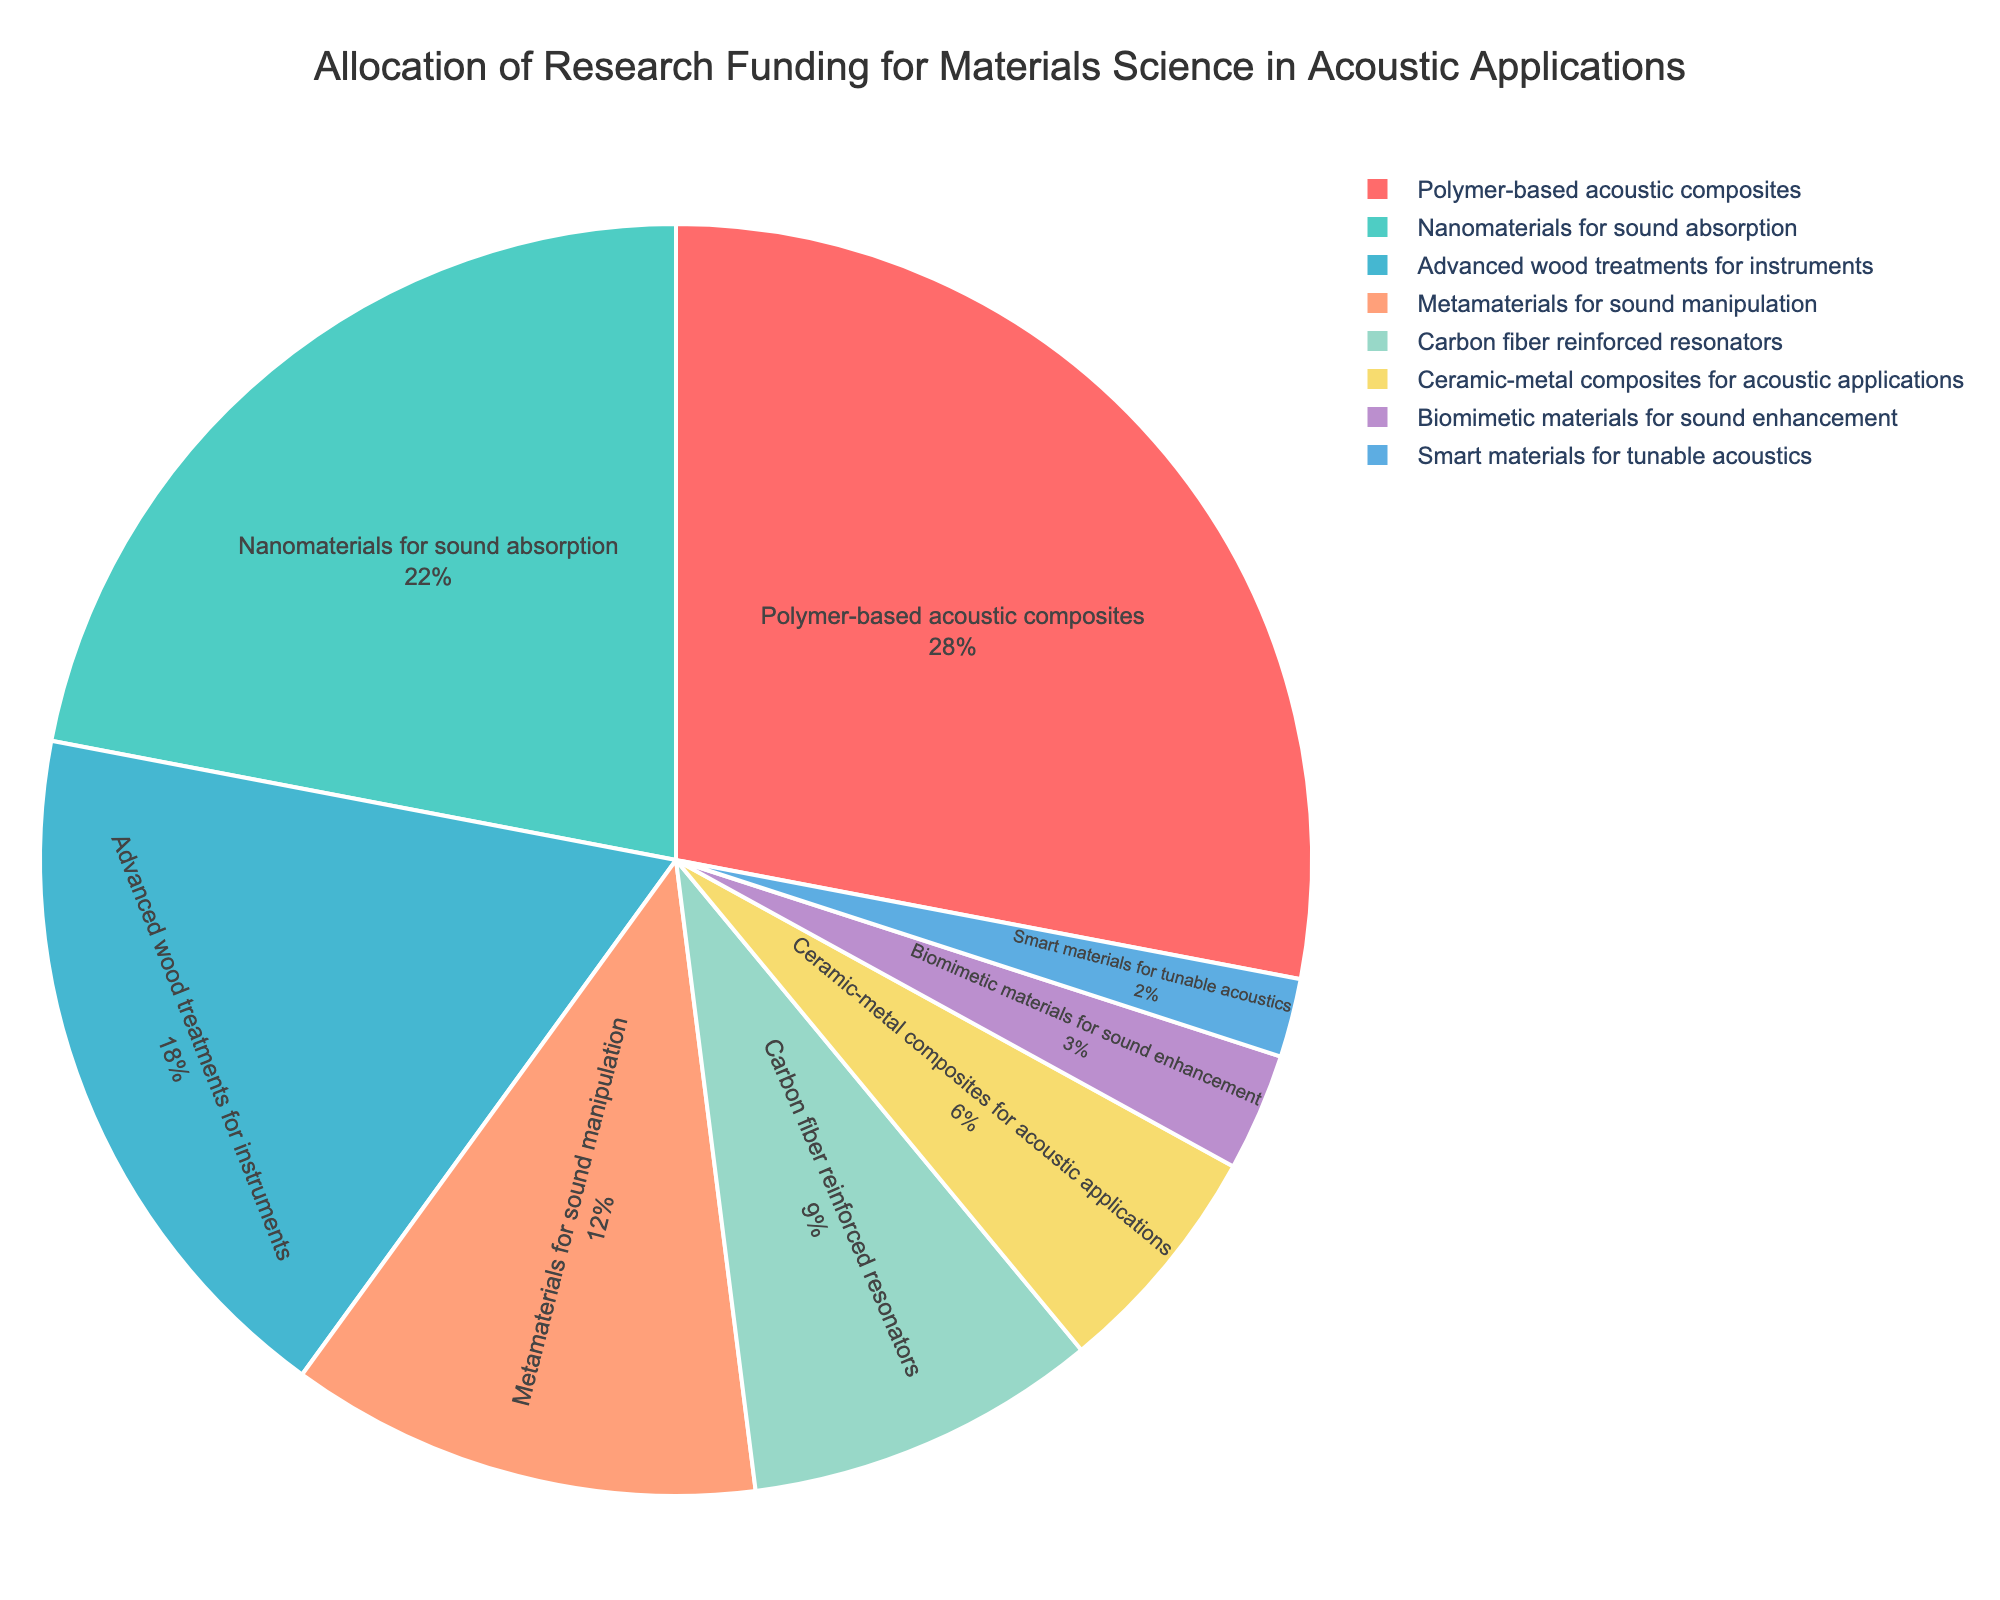What is the largest funding allocation in the research areas? The largest funding allocation is for Polymer-based acoustic composites, as it has the highest percentage in the pie chart.
Answer: Polymer-based acoustic composites Which three research areas have the lowest funding percentages? The three lowest funding percentages are observed for Biomimetic materials for sound enhancement, Smart materials for tunable acoustics, and Ceramic-metal composites for acoustic applications, based on the smallest segments in the pie chart.
Answer: Biomimetic materials for sound enhancement, Smart materials for tunable acoustics, Ceramic-metal composites for acoustic applications What percentage of the total funding is allocated to Nanomaterials for sound absorption and Advanced wood treatments for instruments combined? Adding the funding percentages of Nanomaterials for sound absorption (22%) and Advanced wood treatments for instruments (18%) gives a combined total of 40%.
Answer: 40% How much more funding is allocated to Polymer-based acoustic composites compared to Carbon fiber reinforced resonators? The funding for Polymer-based acoustic composites is at 28%, and for Carbon fiber reinforced resonators is at 9%. Subtracting these gives 28% - 9% = 19%.
Answer: 19% What is the difference in funding percentage between the top-funded and least-funded research areas? The top-funded area is Polymer-based acoustic composites at 28%, and the least-funded is Smart materials for tunable acoustics at 2%. The difference is 28% - 2% = 26%.
Answer: 26% Which color represents Metamaterials for sound manipulation in the pie chart? The color for Metamaterials for sound manipulation can be identified visually in the pie chart, which in this case is represented by one of the preset colors chosen in the figure.
Answer: [Look for the corresponding color segment in the pie chart; it is the fourth color in the custom palette sequence.] What is the total funding percentage for the research areas focused on sound manipulation and resonators (Metamaterials for sound manipulation and Carbon fiber reinforced resonators)? Adding the percentages for Metamaterials for sound manipulation (12%) and Carbon fiber reinforced resonators (9%) gives a total of 21%.
Answer: 21% Which research area received twice the funding percentage of Ceramic-metal composites for acoustic applications? The Ceramic-metal composites for acoustic applications received 6%. The area with twice this percentage (6% * 2) is 12%, which corresponds to Metamaterials for sound manipulation.
Answer: Metamaterials for sound manipulation What is the median funding percentage allocation among all research areas? Sorting the percentages: (2%, 3%, 6%, 9%, 12%, 18%, 22%, 28%). The median of this even-numbered set is the average of 9% and 12%, which is (9 + 12) / 2 = 10.5%.
Answer: 10.5% 